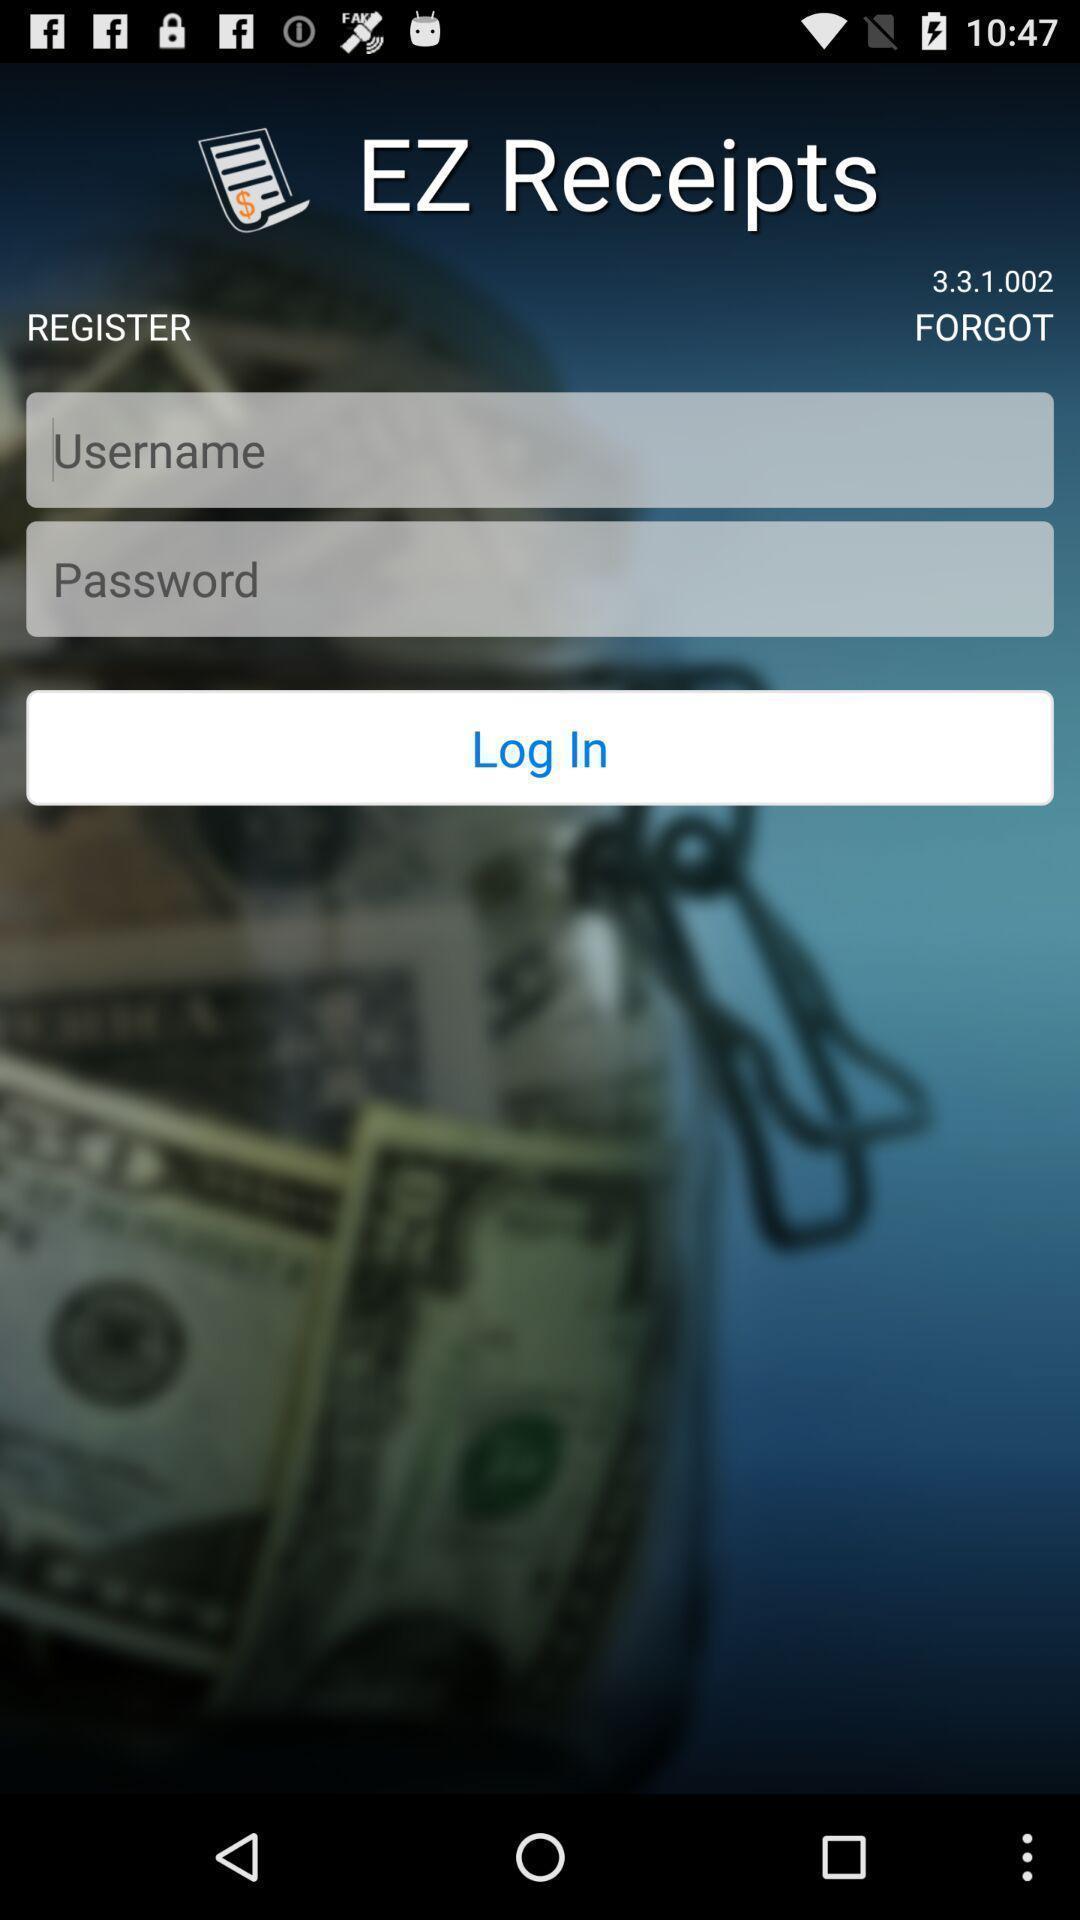What can you discern from this picture? Page displaying signing in information about an application. 